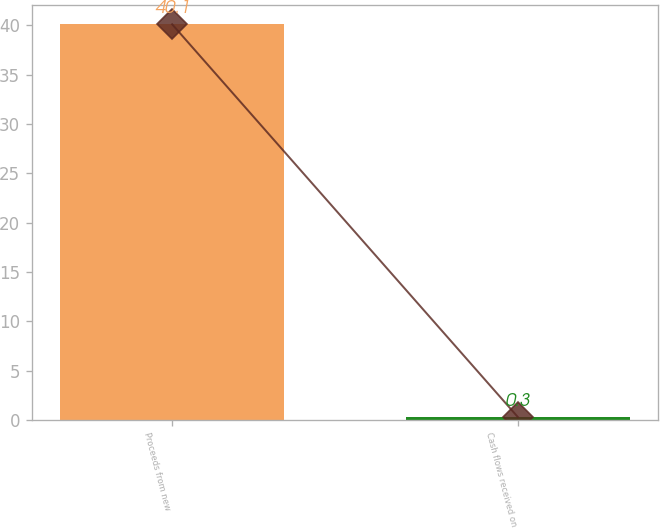<chart> <loc_0><loc_0><loc_500><loc_500><bar_chart><fcel>Proceeds from new<fcel>Cash flows received on<nl><fcel>40.1<fcel>0.3<nl></chart> 